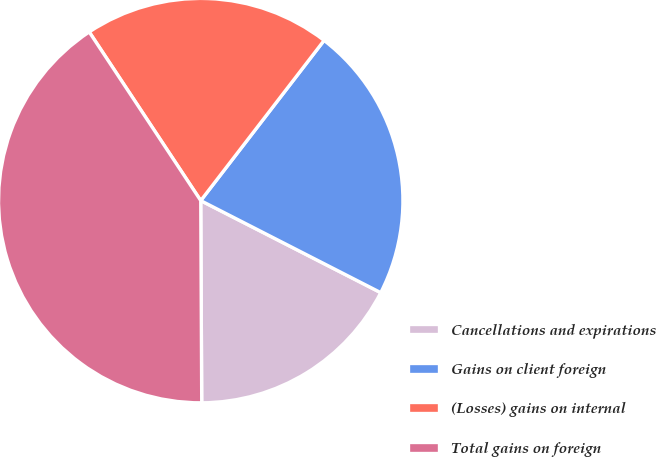Convert chart to OTSL. <chart><loc_0><loc_0><loc_500><loc_500><pie_chart><fcel>Cancellations and expirations<fcel>Gains on client foreign<fcel>(Losses) gains on internal<fcel>Total gains on foreign<nl><fcel>17.4%<fcel>22.08%<fcel>19.74%<fcel>40.78%<nl></chart> 